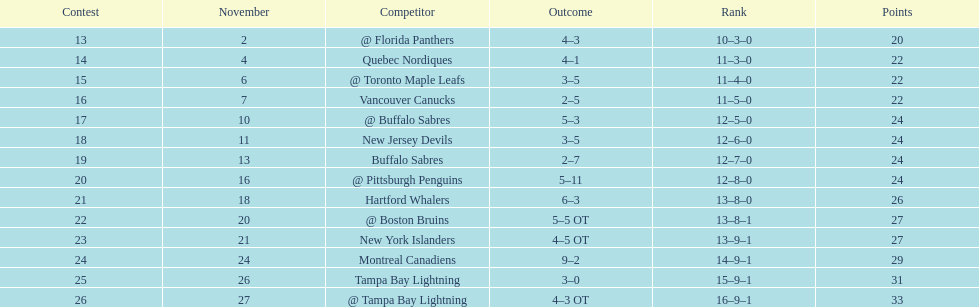What was the number of wins the philadelphia flyers had? 35. 